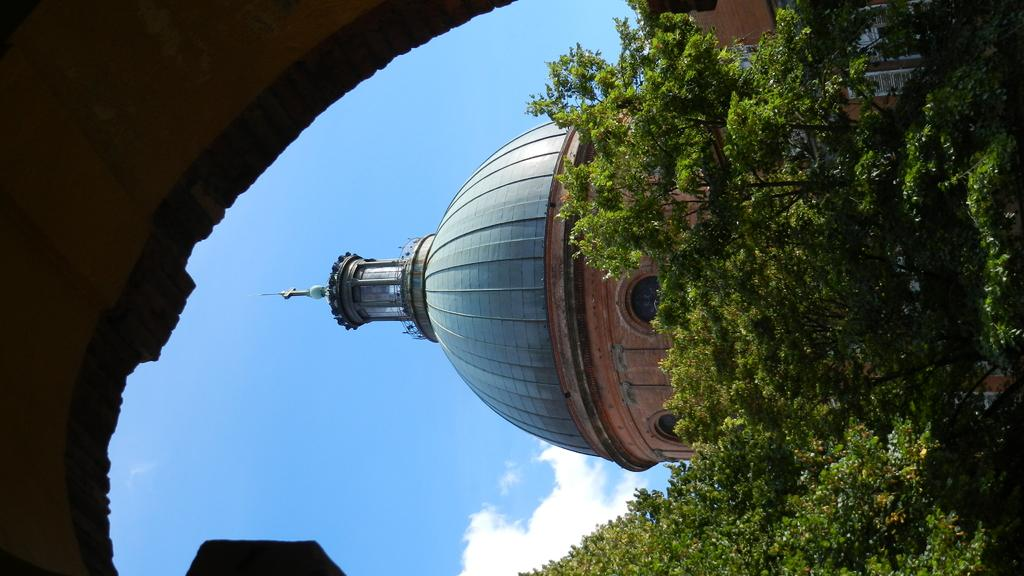What type of vegetation can be seen in the image? There are trees in the image. What type of structure is present in the image? There is a building with windows in the image. What else can be seen in the image besides trees and the building? There are objects in the image. What can be seen in the background of the image? The sky is visible in the background of the image. Is there a beggar asking for money in the image? There is no beggar present in the image. Can you see an airplane flying in the sky in the image? There is no airplane visible in the sky in the image. 